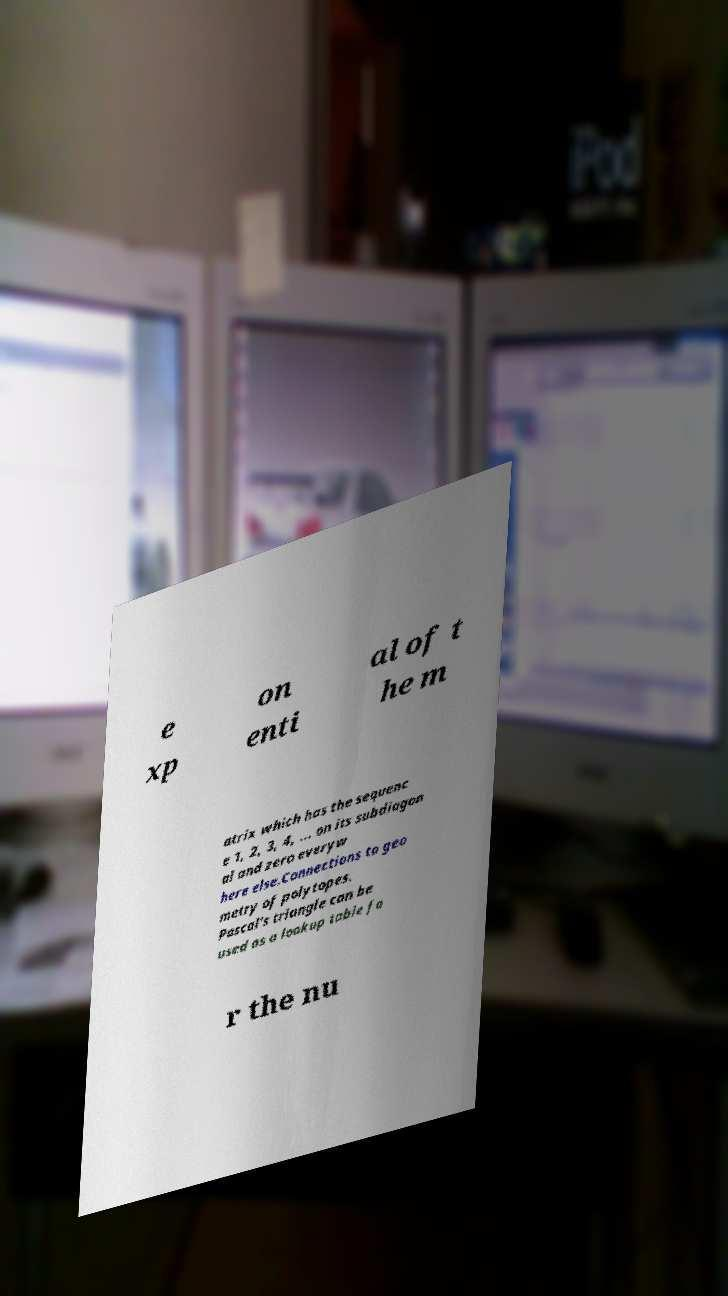Could you assist in decoding the text presented in this image and type it out clearly? e xp on enti al of t he m atrix which has the sequenc e 1, 2, 3, 4, ... on its subdiagon al and zero everyw here else.Connections to geo metry of polytopes. Pascal's triangle can be used as a lookup table fo r the nu 